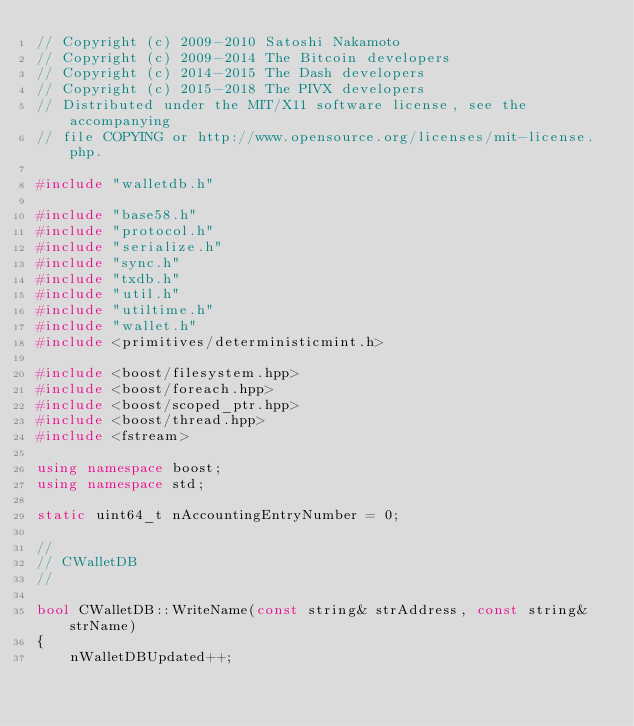<code> <loc_0><loc_0><loc_500><loc_500><_C++_>// Copyright (c) 2009-2010 Satoshi Nakamoto
// Copyright (c) 2009-2014 The Bitcoin developers
// Copyright (c) 2014-2015 The Dash developers
// Copyright (c) 2015-2018 The PIVX developers
// Distributed under the MIT/X11 software license, see the accompanying
// file COPYING or http://www.opensource.org/licenses/mit-license.php.

#include "walletdb.h"

#include "base58.h"
#include "protocol.h"
#include "serialize.h"
#include "sync.h"
#include "txdb.h"
#include "util.h"
#include "utiltime.h"
#include "wallet.h"
#include <primitives/deterministicmint.h>

#include <boost/filesystem.hpp>
#include <boost/foreach.hpp>
#include <boost/scoped_ptr.hpp>
#include <boost/thread.hpp>
#include <fstream>

using namespace boost;
using namespace std;

static uint64_t nAccountingEntryNumber = 0;

//
// CWalletDB
//

bool CWalletDB::WriteName(const string& strAddress, const string& strName)
{
    nWalletDBUpdated++;</code> 